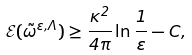Convert formula to latex. <formula><loc_0><loc_0><loc_500><loc_500>\mathcal { E } ( \tilde { \omega } ^ { \varepsilon , \Lambda } ) \geq \frac { \kappa ^ { 2 } } { 4 \pi } \ln { \frac { 1 } { \varepsilon } } - C ,</formula> 